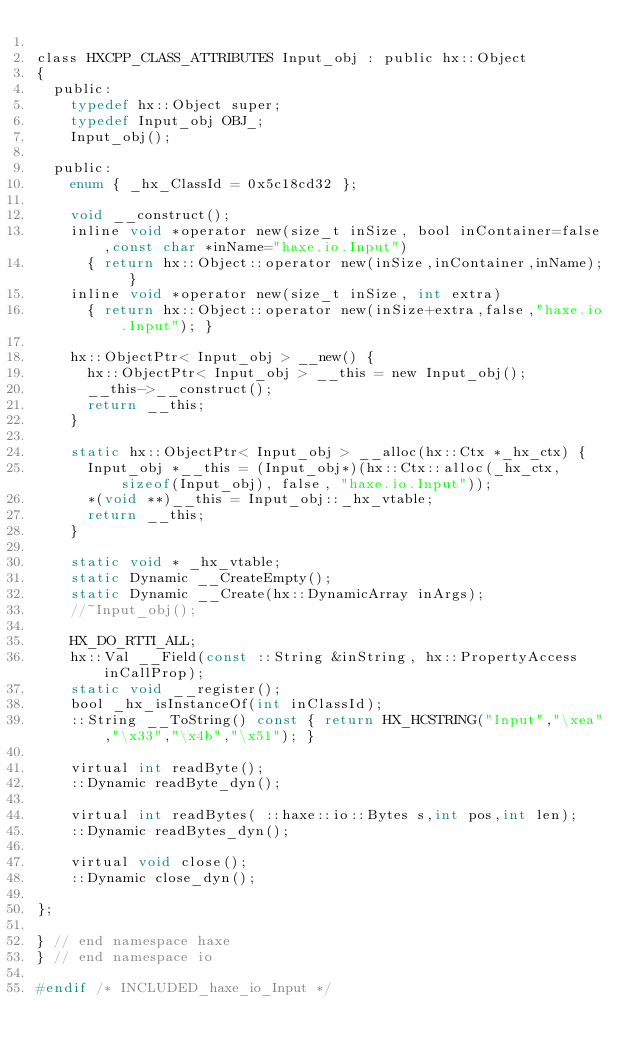Convert code to text. <code><loc_0><loc_0><loc_500><loc_500><_C_>
class HXCPP_CLASS_ATTRIBUTES Input_obj : public hx::Object
{
	public:
		typedef hx::Object super;
		typedef Input_obj OBJ_;
		Input_obj();

	public:
		enum { _hx_ClassId = 0x5c18cd32 };

		void __construct();
		inline void *operator new(size_t inSize, bool inContainer=false,const char *inName="haxe.io.Input")
			{ return hx::Object::operator new(inSize,inContainer,inName); }
		inline void *operator new(size_t inSize, int extra)
			{ return hx::Object::operator new(inSize+extra,false,"haxe.io.Input"); }

		hx::ObjectPtr< Input_obj > __new() {
			hx::ObjectPtr< Input_obj > __this = new Input_obj();
			__this->__construct();
			return __this;
		}

		static hx::ObjectPtr< Input_obj > __alloc(hx::Ctx *_hx_ctx) {
			Input_obj *__this = (Input_obj*)(hx::Ctx::alloc(_hx_ctx, sizeof(Input_obj), false, "haxe.io.Input"));
			*(void **)__this = Input_obj::_hx_vtable;
			return __this;
		}

		static void * _hx_vtable;
		static Dynamic __CreateEmpty();
		static Dynamic __Create(hx::DynamicArray inArgs);
		//~Input_obj();

		HX_DO_RTTI_ALL;
		hx::Val __Field(const ::String &inString, hx::PropertyAccess inCallProp);
		static void __register();
		bool _hx_isInstanceOf(int inClassId);
		::String __ToString() const { return HX_HCSTRING("Input","\xea","\x33","\x4b","\x51"); }

		virtual int readByte();
		::Dynamic readByte_dyn();

		virtual int readBytes( ::haxe::io::Bytes s,int pos,int len);
		::Dynamic readBytes_dyn();

		virtual void close();
		::Dynamic close_dyn();

};

} // end namespace haxe
} // end namespace io

#endif /* INCLUDED_haxe_io_Input */ 
</code> 